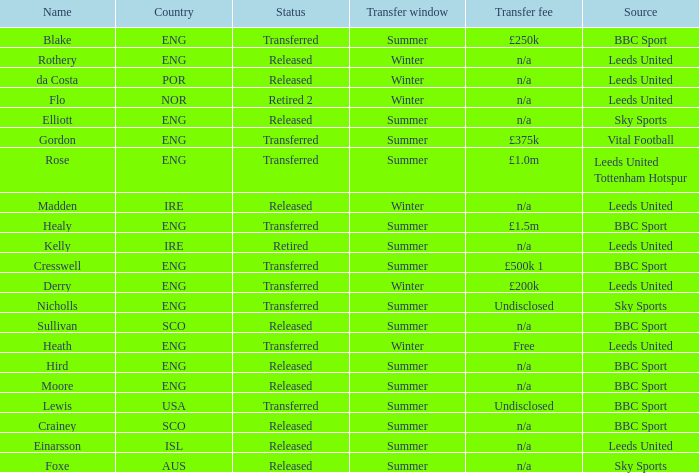What is the person's name that is from the country of SCO? Crainey, Sullivan. 